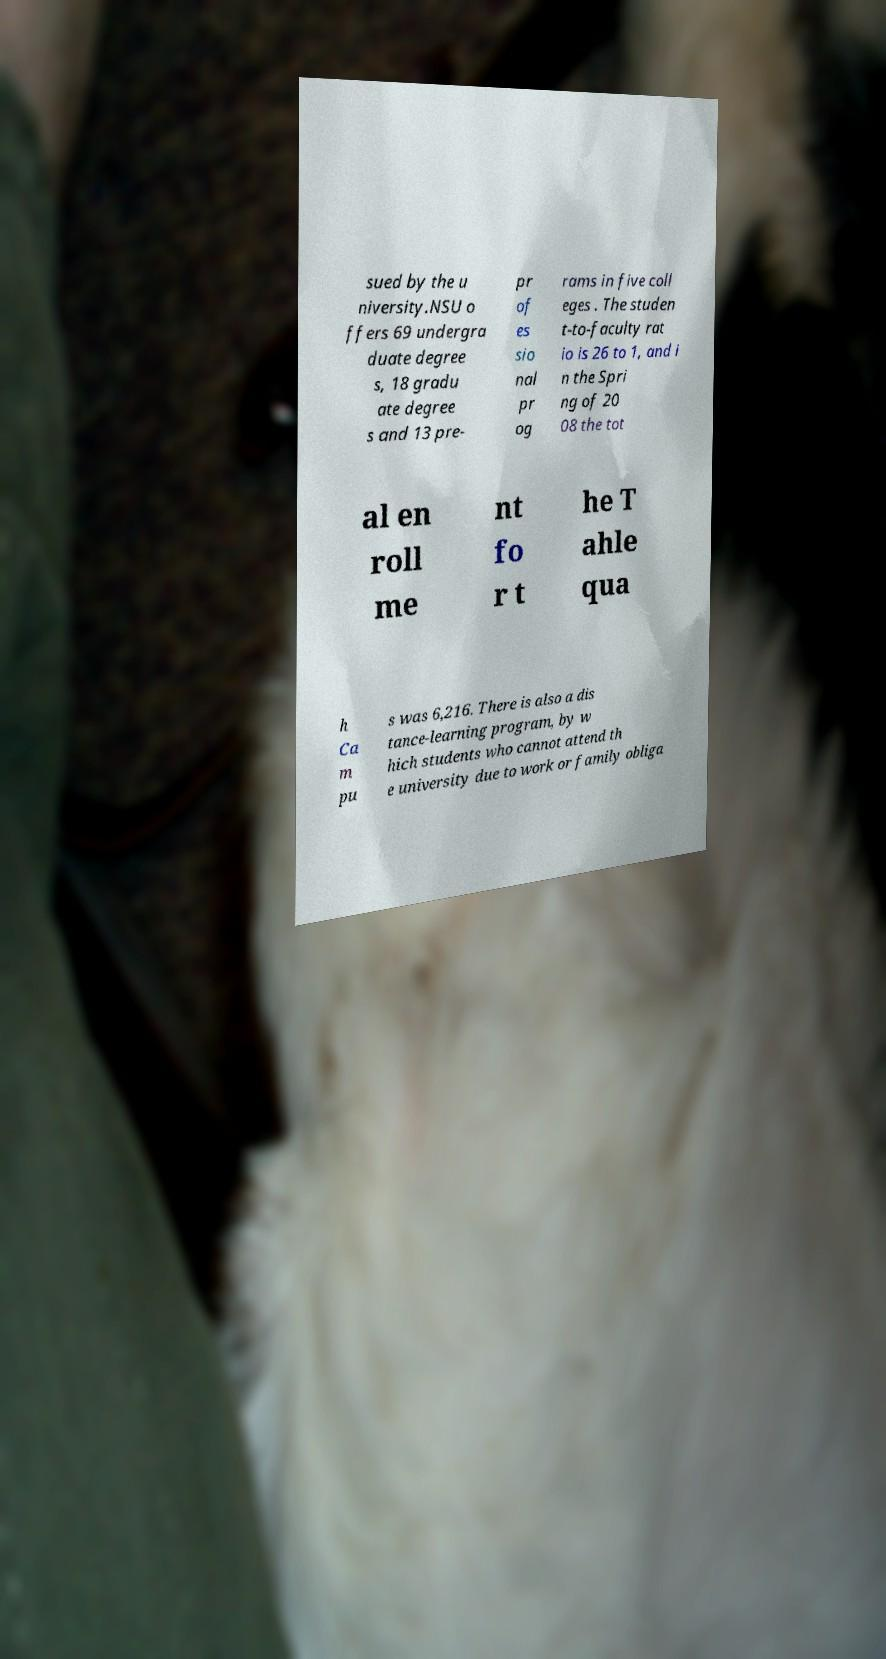There's text embedded in this image that I need extracted. Can you transcribe it verbatim? sued by the u niversity.NSU o ffers 69 undergra duate degree s, 18 gradu ate degree s and 13 pre- pr of es sio nal pr og rams in five coll eges . The studen t-to-faculty rat io is 26 to 1, and i n the Spri ng of 20 08 the tot al en roll me nt fo r t he T ahle qua h Ca m pu s was 6,216. There is also a dis tance-learning program, by w hich students who cannot attend th e university due to work or family obliga 